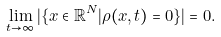<formula> <loc_0><loc_0><loc_500><loc_500>\lim _ { t \rightarrow \infty } | \{ x \in \mathbb { R } ^ { N } | \rho ( x , t ) = 0 \} | = 0 .</formula> 